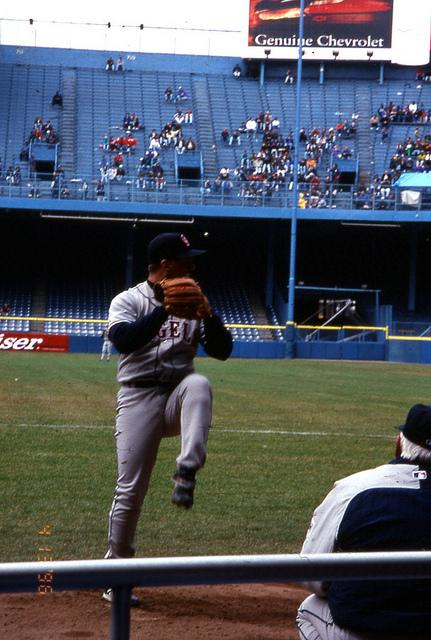What is the nickname of the motor vehicle company advertised?

Choices:
A) prius
B) chevy
C) hummer
D) beamer chevy 